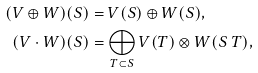<formula> <loc_0><loc_0><loc_500><loc_500>( V \oplus W ) ( S ) & = V ( S ) \oplus W ( S ) , \\ ( V \cdot W ) ( S ) & = \bigoplus _ { T \subset S } V ( T ) \otimes W ( S \ T ) ,</formula> 